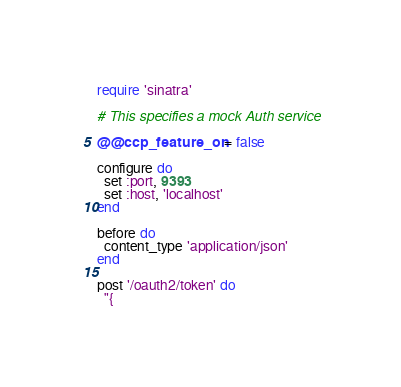<code> <loc_0><loc_0><loc_500><loc_500><_Ruby_>require 'sinatra'

# This specifies a mock Auth service

@@ccp_feature_on = false

configure do
  set :port, 9393
  set :host, 'localhost'
end

before do
  content_type 'application/json'
end

post '/oauth2/token' do
  "{</code> 